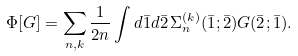<formula> <loc_0><loc_0><loc_500><loc_500>\Phi [ G ] = \sum _ { n , k } \frac { 1 } { 2 n } \int d \bar { 1 } d \bar { 2 } \, \Sigma _ { n } ^ { ( k ) } ( \bar { 1 } ; \bar { 2 } ) G ( \bar { 2 } ; \bar { 1 } ) .</formula> 